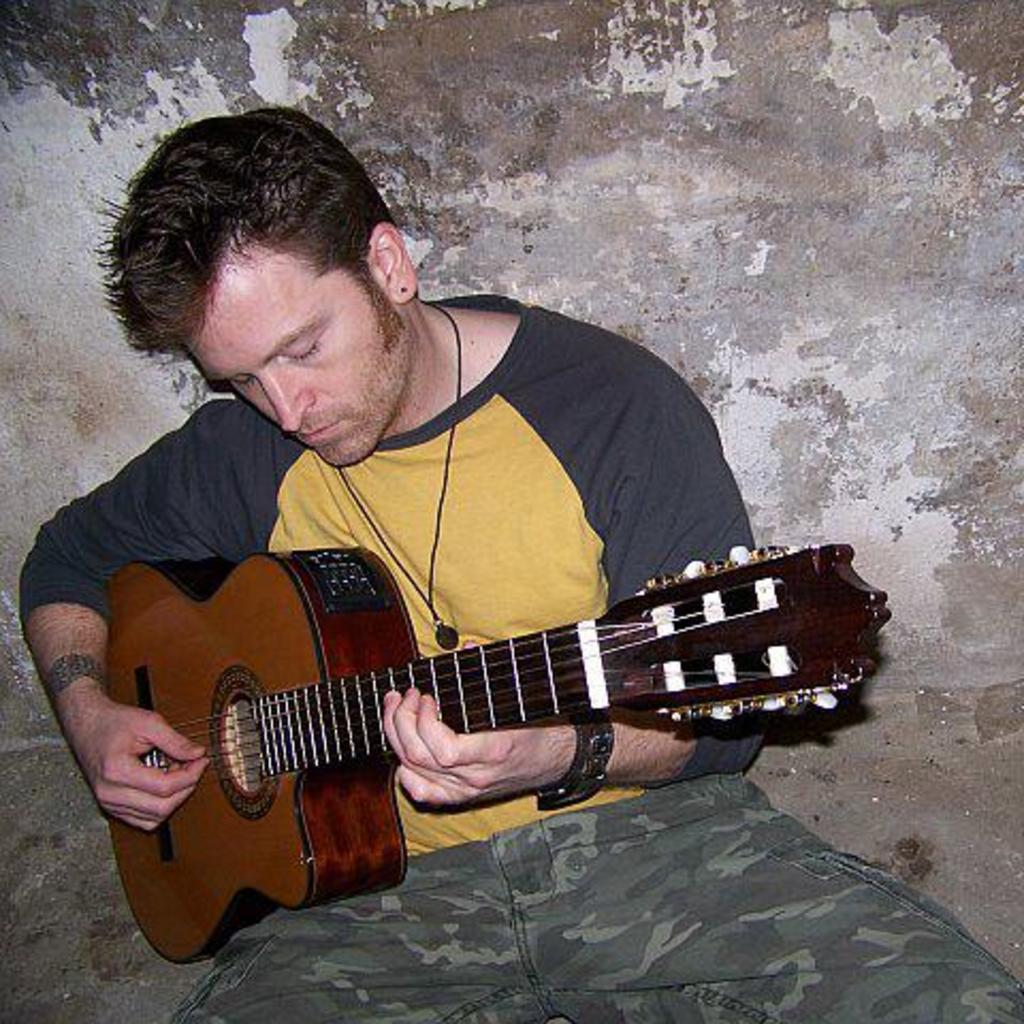Who is present in the image? There is a person in the image. What is the person doing in the image? The person is sitting and holding a guitar. What might the person be doing with the guitar? The person is likely playing the guitar. What type of anger is the person expressing in the image? There is no indication of anger in the image; the person is simply sitting and holding a guitar. 